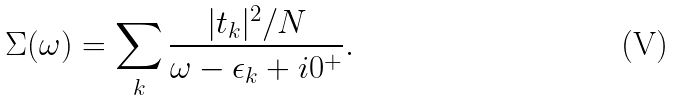<formula> <loc_0><loc_0><loc_500><loc_500>\Sigma ( \omega ) = \sum _ { k } \frac { | t _ { k } | ^ { 2 } / N } { \omega - \epsilon _ { k } + i 0 ^ { + } } .</formula> 